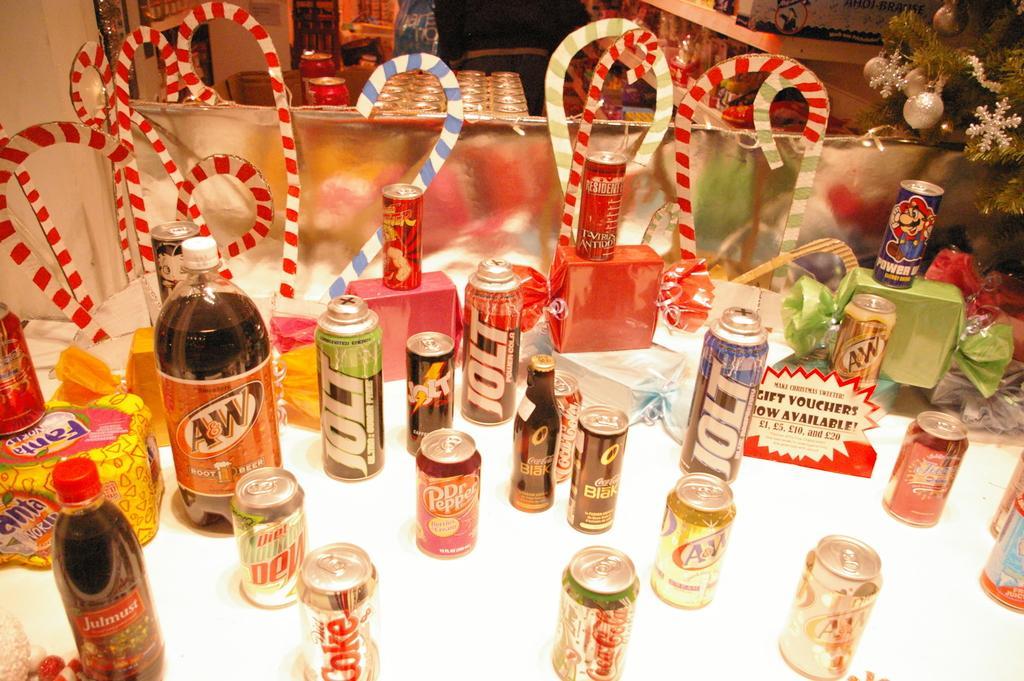Describe this image in one or two sentences. In the image we can see there are cold drink cans, cold drink bottles and candy sticks kept on the table. 